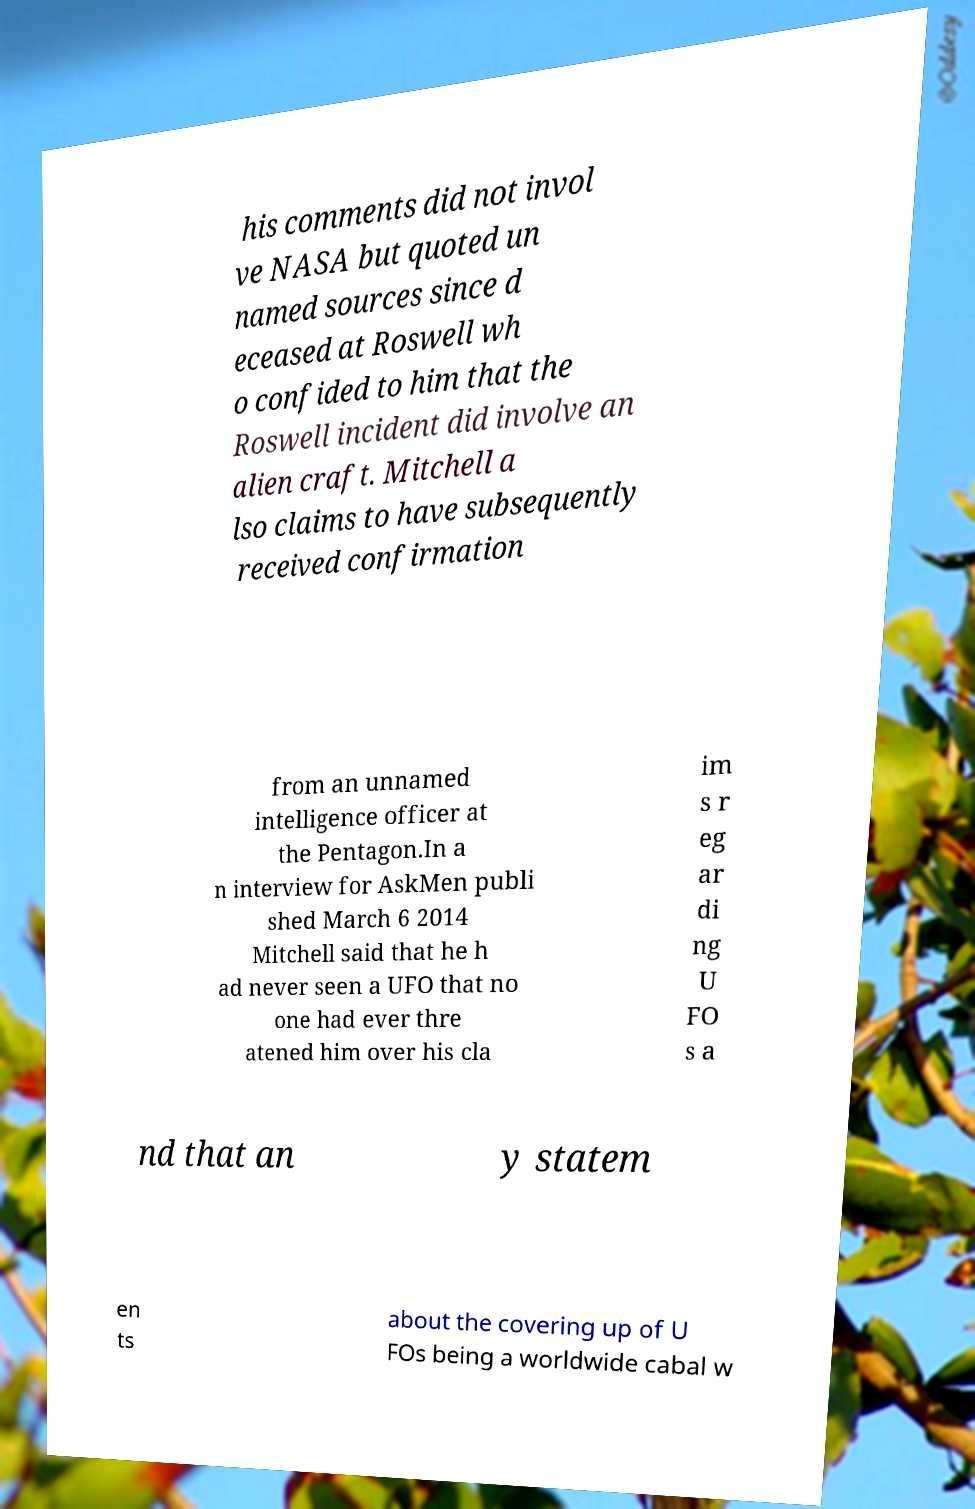Please identify and transcribe the text found in this image. his comments did not invol ve NASA but quoted un named sources since d eceased at Roswell wh o confided to him that the Roswell incident did involve an alien craft. Mitchell a lso claims to have subsequently received confirmation from an unnamed intelligence officer at the Pentagon.In a n interview for AskMen publi shed March 6 2014 Mitchell said that he h ad never seen a UFO that no one had ever thre atened him over his cla im s r eg ar di ng U FO s a nd that an y statem en ts about the covering up of U FOs being a worldwide cabal w 